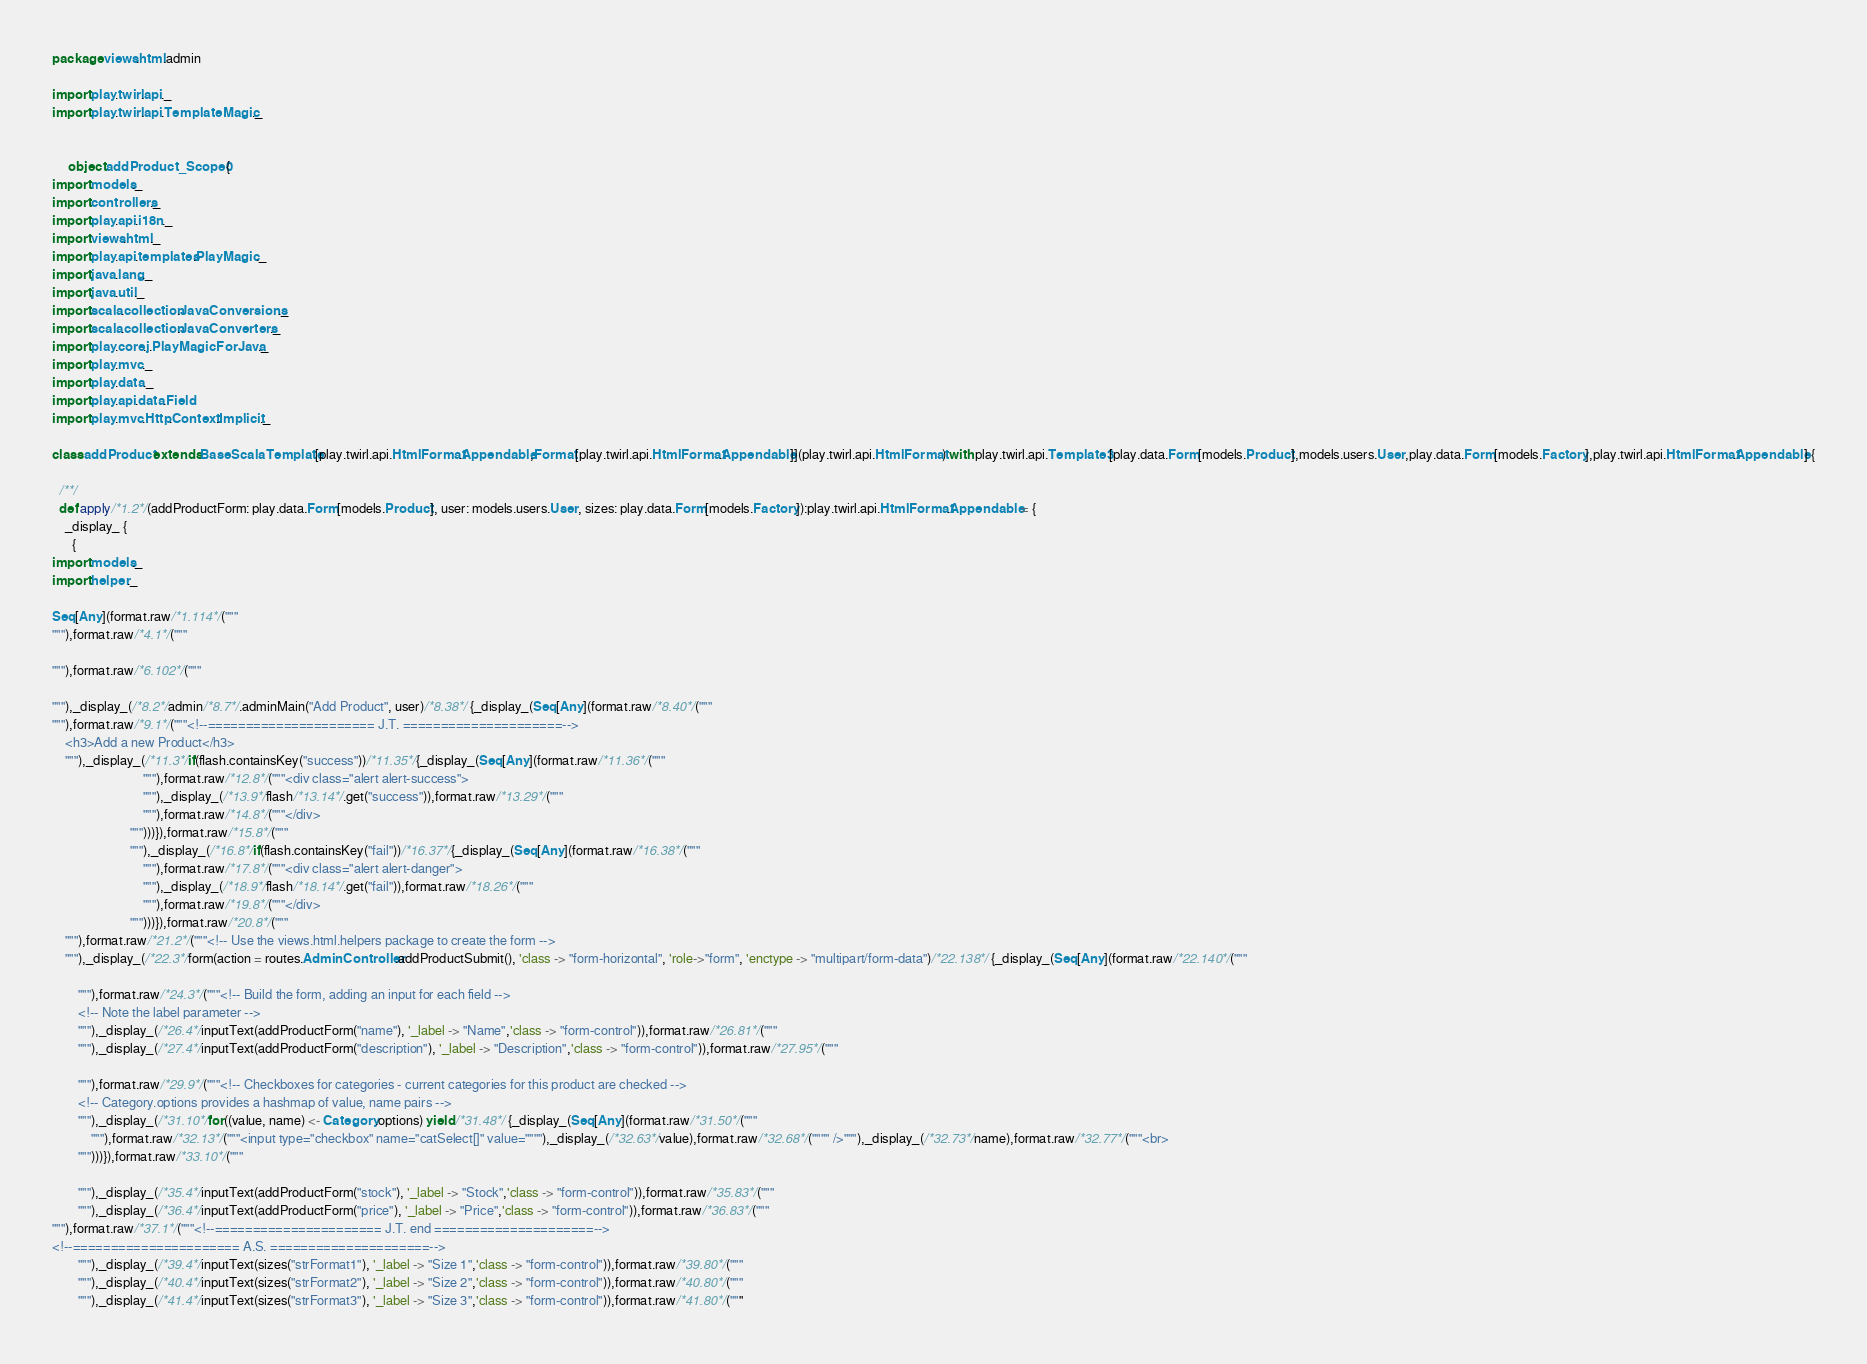<code> <loc_0><loc_0><loc_500><loc_500><_Scala_>
package views.html.admin

import play.twirl.api._
import play.twirl.api.TemplateMagic._


     object addProduct_Scope0 {
import models._
import controllers._
import play.api.i18n._
import views.html._
import play.api.templates.PlayMagic._
import java.lang._
import java.util._
import scala.collection.JavaConversions._
import scala.collection.JavaConverters._
import play.core.j.PlayMagicForJava._
import play.mvc._
import play.data._
import play.api.data.Field
import play.mvc.Http.Context.Implicit._

class addProduct extends BaseScalaTemplate[play.twirl.api.HtmlFormat.Appendable,Format[play.twirl.api.HtmlFormat.Appendable]](play.twirl.api.HtmlFormat) with play.twirl.api.Template3[play.data.Form[models.Product],models.users.User,play.data.Form[models.Factory],play.twirl.api.HtmlFormat.Appendable] {

  /**/
  def apply/*1.2*/(addProductForm: play.data.Form[models.Product], user: models.users.User, sizes: play.data.Form[models.Factory]):play.twirl.api.HtmlFormat.Appendable = {
    _display_ {
      {
import models._
import helper._

Seq[Any](format.raw/*1.114*/("""
"""),format.raw/*4.1*/("""

"""),format.raw/*6.102*/("""

"""),_display_(/*8.2*/admin/*8.7*/.adminMain("Add Product", user)/*8.38*/ {_display_(Seq[Any](format.raw/*8.40*/("""
"""),format.raw/*9.1*/("""<!--====================== J.T. =====================-->
	<h3>Add a new Product</h3>
	"""),_display_(/*11.3*/if(flash.containsKey("success"))/*11.35*/{_display_(Seq[Any](format.raw/*11.36*/("""
							"""),format.raw/*12.8*/("""<div class="alert alert-success">
							"""),_display_(/*13.9*/flash/*13.14*/.get("success")),format.raw/*13.29*/("""
							"""),format.raw/*14.8*/("""</div>
						""")))}),format.raw/*15.8*/("""
						"""),_display_(/*16.8*/if(flash.containsKey("fail"))/*16.37*/{_display_(Seq[Any](format.raw/*16.38*/("""
							"""),format.raw/*17.8*/("""<div class="alert alert-danger">
							"""),_display_(/*18.9*/flash/*18.14*/.get("fail")),format.raw/*18.26*/("""
							"""),format.raw/*19.8*/("""</div>
						""")))}),format.raw/*20.8*/("""
	"""),format.raw/*21.2*/("""<!-- Use the views.html.helpers package to create the form -->
	"""),_display_(/*22.3*/form(action = routes.AdminController.addProductSubmit(), 'class -> "form-horizontal", 'role->"form", 'enctype -> "multipart/form-data")/*22.138*/ {_display_(Seq[Any](format.raw/*22.140*/("""
		
		"""),format.raw/*24.3*/("""<!-- Build the form, adding an input for each field -->
		<!-- Note the label parameter -->
		"""),_display_(/*26.4*/inputText(addProductForm("name"), '_label -> "Name",'class -> "form-control")),format.raw/*26.81*/("""
		"""),_display_(/*27.4*/inputText(addProductForm("description"), '_label -> "Description",'class -> "form-control")),format.raw/*27.95*/("""

        """),format.raw/*29.9*/("""<!-- Checkboxes for categories - current categories for this product are checked -->
        <!-- Category.options provides a hashmap of value, name pairs -->
        """),_display_(/*31.10*/for((value, name) <- Category.options) yield /*31.48*/ {_display_(Seq[Any](format.raw/*31.50*/("""
            """),format.raw/*32.13*/("""<input type="checkbox" name="catSelect[]" value=""""),_display_(/*32.63*/value),format.raw/*32.68*/("""" />"""),_display_(/*32.73*/name),format.raw/*32.77*/("""<br>        
        """)))}),format.raw/*33.10*/("""

		"""),_display_(/*35.4*/inputText(addProductForm("stock"), '_label -> "Stock",'class -> "form-control")),format.raw/*35.83*/("""
		"""),_display_(/*36.4*/inputText(addProductForm("price"), '_label -> "Price",'class -> "form-control")),format.raw/*36.83*/("""
"""),format.raw/*37.1*/("""<!--====================== J.T. end =====================-->
<!--====================== A.S. =====================-->
		"""),_display_(/*39.4*/inputText(sizes("strFormat1"), '_label -> "Size 1",'class -> "form-control")),format.raw/*39.80*/("""
		"""),_display_(/*40.4*/inputText(sizes("strFormat2"), '_label -> "Size 2",'class -> "form-control")),format.raw/*40.80*/("""
		"""),_display_(/*41.4*/inputText(sizes("strFormat3"), '_label -> "Size 3",'class -> "form-control")),format.raw/*41.80*/("""</code> 